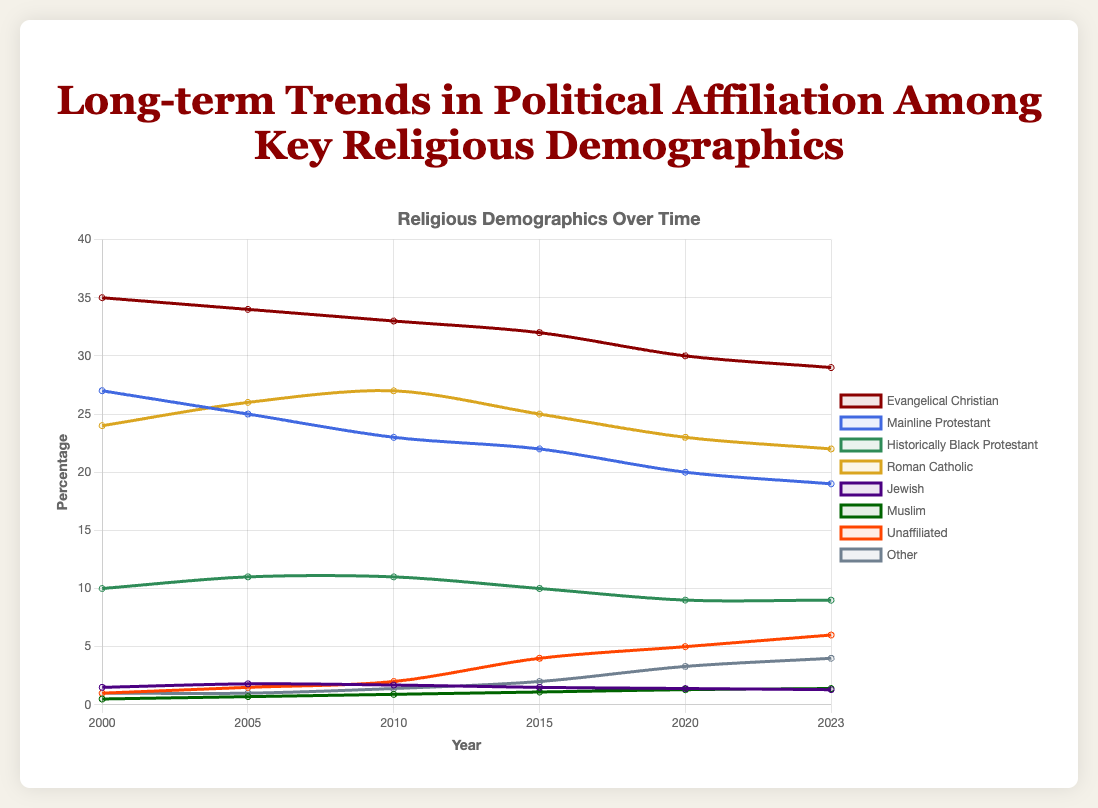Which religious demographic saw the largest increase in percentage from 2000 to 2023? Compare the initial and final values of each religious group from 2000 to 2023. Evangelical Christian decreased from 35% to 29%, Mainline Protestant decreased from 27% to 19%, Historically Black Protestant decreased from 10% to 9%, Roman Catholic decreased from 24% to 22%, Jewish decreased from 1.5% to 1.3%, Muslim increased from 0.5% to 1.4%, Unaffiliated increased from 1% to 6%, and Other increased from 1% to 4%. The Unaffiliated group saw the largest increase.
Answer: Unaffiliated Which year did the Evangelical Christian group have the highest percentage? Review the Evangelical Christian data points across all years. The values are 35% in 2000, 34% in 2005, 33% in 2010, 32% in 2015, 30% in 2020, and 29% in 2023. The highest value of 35% occurs in the year 2000.
Answer: 2000 What is the difference in the Roman Catholic percentage between 2005 and 2023? Locate the Roman Catholic percentages for the years 2005 and 2023, which are 26% and 22% respectively. Subtract the 2023 value from the 2005 value: 26% - 22% = 4%.
Answer: 4% Which religious demographics show a continuously decreasing trend from 2000 to 2023? Analyze the data trend for each group across the years. Any group that constantly decreases without any increase fits. Evangelical Christian (35 to 29), Mainline Protestant (27 to 19), Historically Black Protestant (10 to 9), Roman Catholic (24 to 22), and Jewish (1.5 to 1.3) show continuous decreases.
Answer: Evangelical Christian, Mainline Protestant, Historically Black Protestant, Roman Catholic, Jewish In which year did 'Other' exceed 'Jewish' in percentage for the first time? Compare the percentage points of 'Other' and 'Jewish’ from year to year. In 2010, 'Other' (1.4%) first exceeds 'Jewish' (1.7%), and in 2015 'Other' (2%) exceeds 'Jewish' (1.5%). The first occurrence is in 2010.
Answer: 2010 What is the combined percentage for Unaffiliated and Muslim groups in 2023? Find the percentages for Unaffiliated and Muslim in 2023, which are 6% and 1.4% respectively. Add these two values: 6% + 1.4% = 7.4%.
Answer: 7.4% Which demographic group had a percentage of exactly 10% at any point in the data? Review the data for any group that had a percentage value of exactly 10%. Historically Black Protestant shows a value of 10% in 2000 and 2015.
Answer: Historically Black Protestant 